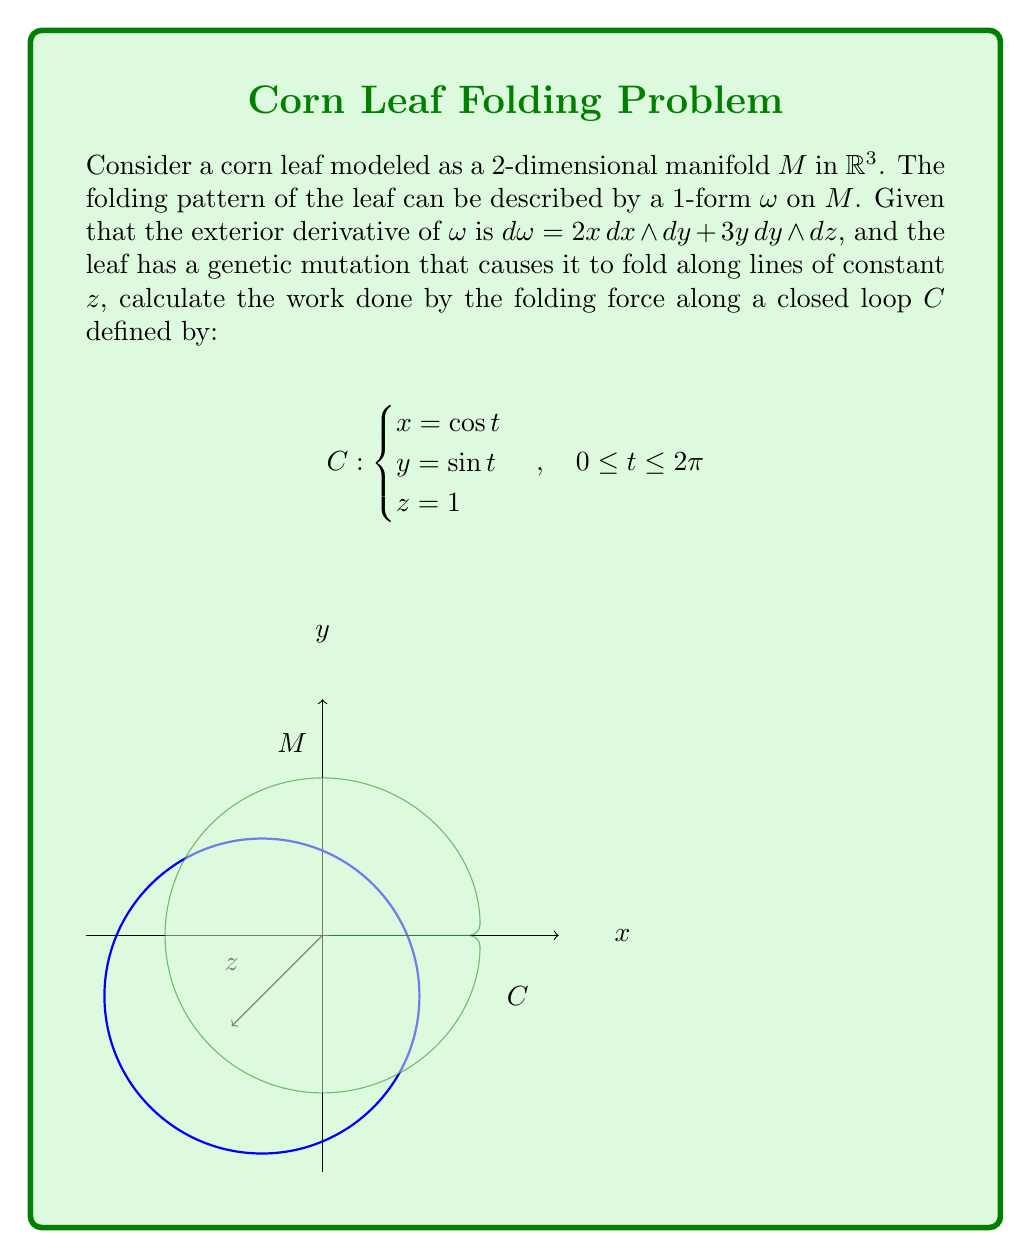Solve this math problem. Let's approach this step-by-step:

1) First, we need to find $\omega$. We're given $d\omega$, so we can integrate:
   $$\omega = x^2dy - 3yz\,dx + f(x,z)\,dz$$
   where $f(x,z)$ is an arbitrary function of $x$ and $z$.

2) Since the leaf folds along lines of constant $z$, the $dz$ component doesn't contribute to the folding force. We can ignore $f(x,z)\,dz$.

3) The work done is given by the line integral $\oint_C \omega$. We need to express this in terms of $t$:
   $$\oint_C \omega = \int_0^{2\pi} (\cos^2 t \cdot (-\sin t) - 3\sin t \cdot 1 \cdot (-\sin t)) dt$$

4) Simplify:
   $$\int_0^{2\pi} (-\cos^2 t \sin t + 3\sin^2 t) dt$$

5) Use trigonometric identities:
   $$\int_0^{2\pi} (-\frac{1}{4}\sin 2t + \frac{3}{2}(1-\cos 2t)) dt$$

6) Integrate:
   $$[-\frac{1}{8}\cos 2t + \frac{3}{2}t - \frac{3}{4}\sin 2t]_0^{2\pi}$$

7) Evaluate:
   $$(-\frac{1}{8} + 3\pi - 0) - (-\frac{1}{8} + 0 - 0) = 3\pi$$

Therefore, the work done by the folding force along the closed loop $C$ is $3\pi$.
Answer: $3\pi$ 